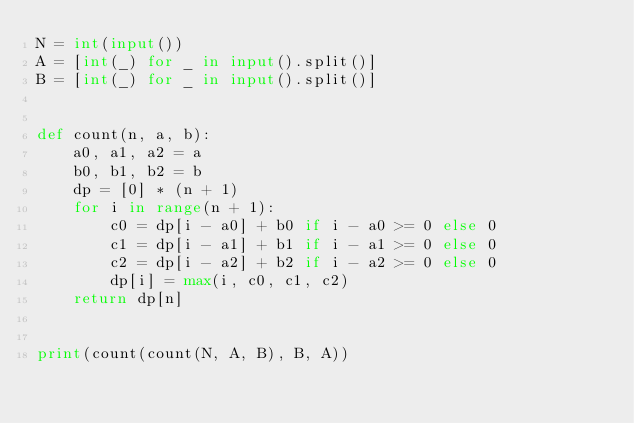<code> <loc_0><loc_0><loc_500><loc_500><_Python_>N = int(input())
A = [int(_) for _ in input().split()]
B = [int(_) for _ in input().split()]


def count(n, a, b):
    a0, a1, a2 = a
    b0, b1, b2 = b
    dp = [0] * (n + 1)
    for i in range(n + 1):
        c0 = dp[i - a0] + b0 if i - a0 >= 0 else 0
        c1 = dp[i - a1] + b1 if i - a1 >= 0 else 0
        c2 = dp[i - a2] + b2 if i - a2 >= 0 else 0
        dp[i] = max(i, c0, c1, c2)
    return dp[n]


print(count(count(N, A, B), B, A))
</code> 